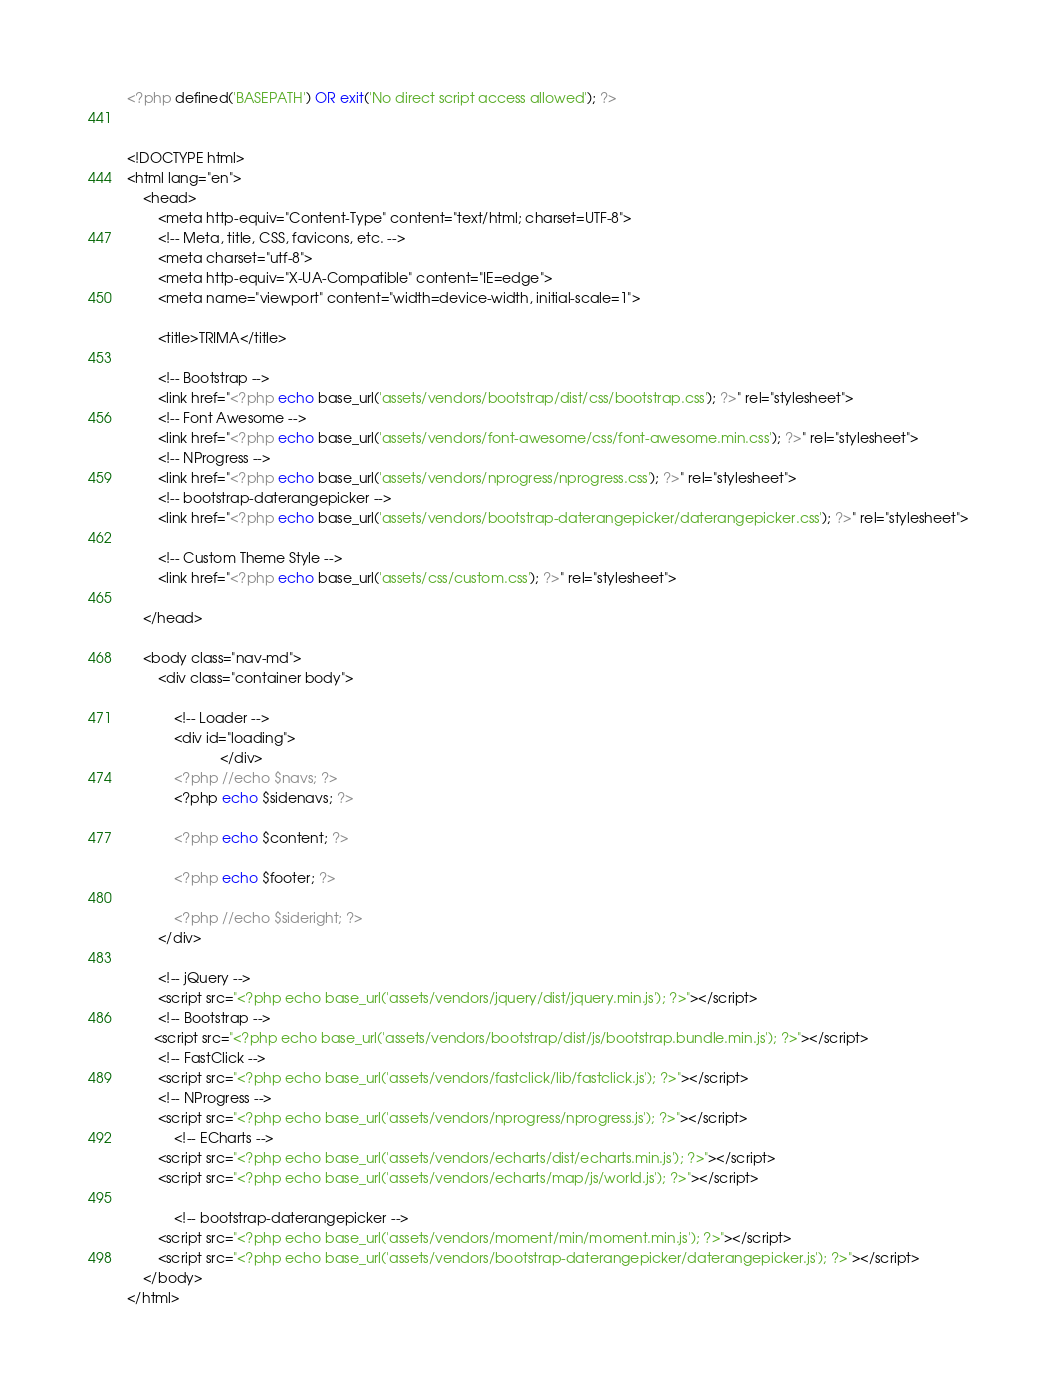<code> <loc_0><loc_0><loc_500><loc_500><_PHP_><?php defined('BASEPATH') OR exit('No direct script access allowed'); ?>


<!DOCTYPE html>
<html lang="en">
	<head>
		<meta http-equiv="Content-Type" content="text/html; charset=UTF-8">
		<!-- Meta, title, CSS, favicons, etc. -->
		<meta charset="utf-8">
		<meta http-equiv="X-UA-Compatible" content="IE=edge">
		<meta name="viewport" content="width=device-width, initial-scale=1">

		<title>TRIMA</title>

		<!-- Bootstrap -->
		<link href="<?php echo base_url('assets/vendors/bootstrap/dist/css/bootstrap.css'); ?>" rel="stylesheet">
		<!-- Font Awesome -->
		<link href="<?php echo base_url('assets/vendors/font-awesome/css/font-awesome.min.css'); ?>" rel="stylesheet">
		<!-- NProgress -->
		<link href="<?php echo base_url('assets/vendors/nprogress/nprogress.css'); ?>" rel="stylesheet">
		<!-- bootstrap-daterangepicker -->
		<link href="<?php echo base_url('assets/vendors/bootstrap-daterangepicker/daterangepicker.css'); ?>" rel="stylesheet">

		<!-- Custom Theme Style -->
		<link href="<?php echo base_url('assets/css/custom.css'); ?>" rel="stylesheet">

	</head>

	<body class="nav-md">
		<div class="container body">
	
			<!-- Loader -->
			<div id="loading">
						</div>
			<?php //echo $navs; ?>
			<?php echo $sidenavs; ?>
			
			<?php echo $content; ?>

			<?php echo $footer; ?>
			
			<?php //echo $sideright; ?>
		</div>

		<!-- jQuery -->
		<script src="<?php echo base_url('assets/vendors/jquery/dist/jquery.min.js'); ?>"></script>
		<!-- Bootstrap -->
	   <script src="<?php echo base_url('assets/vendors/bootstrap/dist/js/bootstrap.bundle.min.js'); ?>"></script>
		<!-- FastClick -->
		<script src="<?php echo base_url('assets/vendors/fastclick/lib/fastclick.js'); ?>"></script>
		<!-- NProgress -->
		<script src="<?php echo base_url('assets/vendors/nprogress/nprogress.js'); ?>"></script>
			<!-- ECharts -->
		<script src="<?php echo base_url('assets/vendors/echarts/dist/echarts.min.js'); ?>"></script>
		<script src="<?php echo base_url('assets/vendors/echarts/map/js/world.js'); ?>"></script>
		
			<!-- bootstrap-daterangepicker -->
		<script src="<?php echo base_url('assets/vendors/moment/min/moment.min.js'); ?>"></script>
		<script src="<?php echo base_url('assets/vendors/bootstrap-daterangepicker/daterangepicker.js'); ?>"></script>
	</body>
</html></code> 